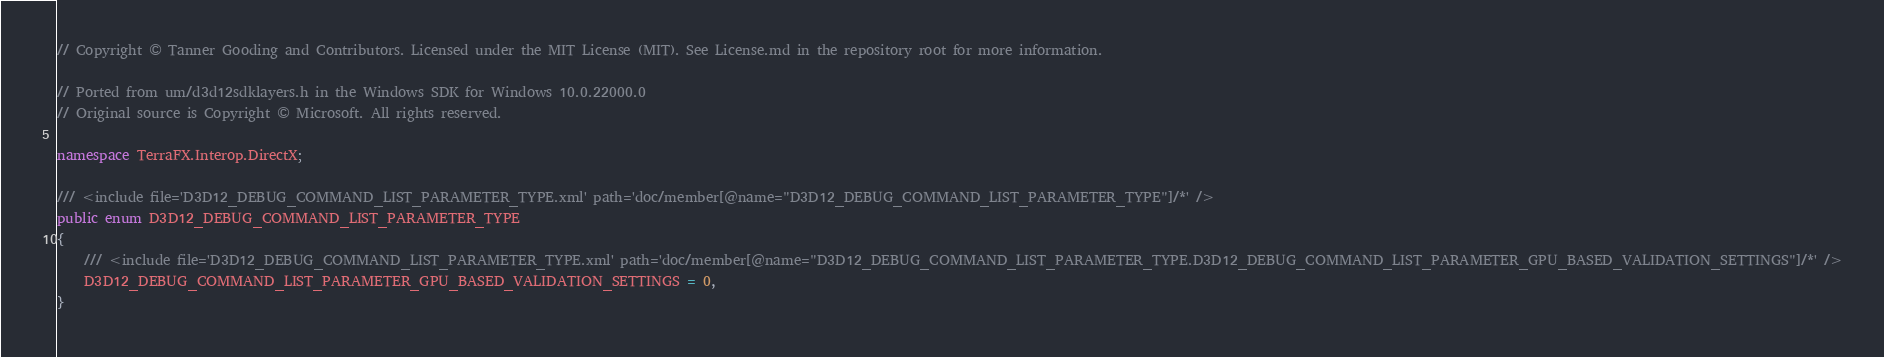<code> <loc_0><loc_0><loc_500><loc_500><_C#_>// Copyright © Tanner Gooding and Contributors. Licensed under the MIT License (MIT). See License.md in the repository root for more information.

// Ported from um/d3d12sdklayers.h in the Windows SDK for Windows 10.0.22000.0
// Original source is Copyright © Microsoft. All rights reserved.

namespace TerraFX.Interop.DirectX;

/// <include file='D3D12_DEBUG_COMMAND_LIST_PARAMETER_TYPE.xml' path='doc/member[@name="D3D12_DEBUG_COMMAND_LIST_PARAMETER_TYPE"]/*' />
public enum D3D12_DEBUG_COMMAND_LIST_PARAMETER_TYPE
{
    /// <include file='D3D12_DEBUG_COMMAND_LIST_PARAMETER_TYPE.xml' path='doc/member[@name="D3D12_DEBUG_COMMAND_LIST_PARAMETER_TYPE.D3D12_DEBUG_COMMAND_LIST_PARAMETER_GPU_BASED_VALIDATION_SETTINGS"]/*' />
    D3D12_DEBUG_COMMAND_LIST_PARAMETER_GPU_BASED_VALIDATION_SETTINGS = 0,
}
</code> 